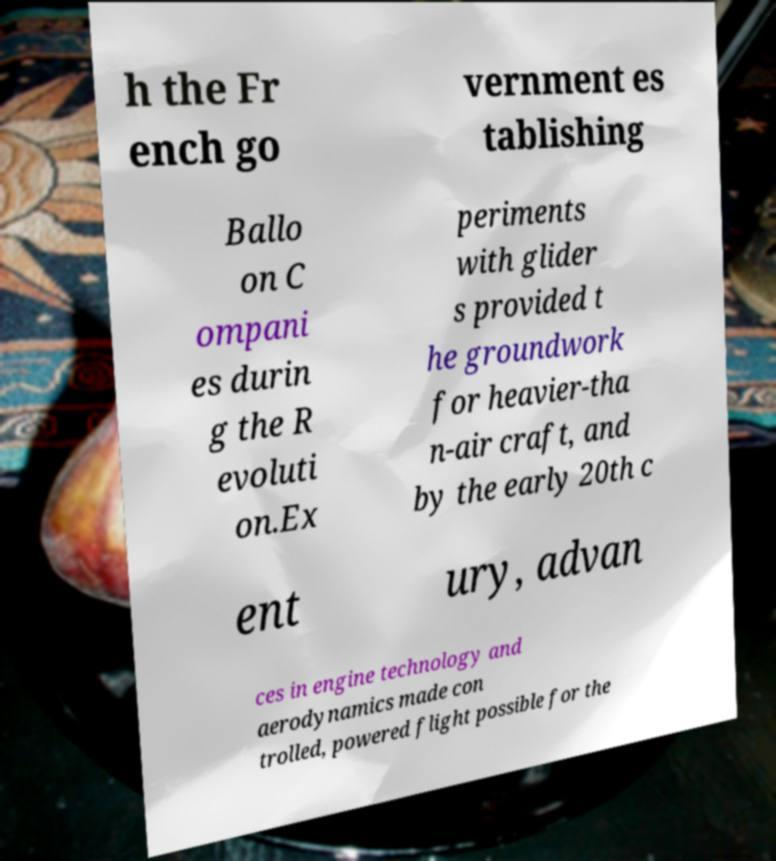For documentation purposes, I need the text within this image transcribed. Could you provide that? h the Fr ench go vernment es tablishing Ballo on C ompani es durin g the R evoluti on.Ex periments with glider s provided t he groundwork for heavier-tha n-air craft, and by the early 20th c ent ury, advan ces in engine technology and aerodynamics made con trolled, powered flight possible for the 